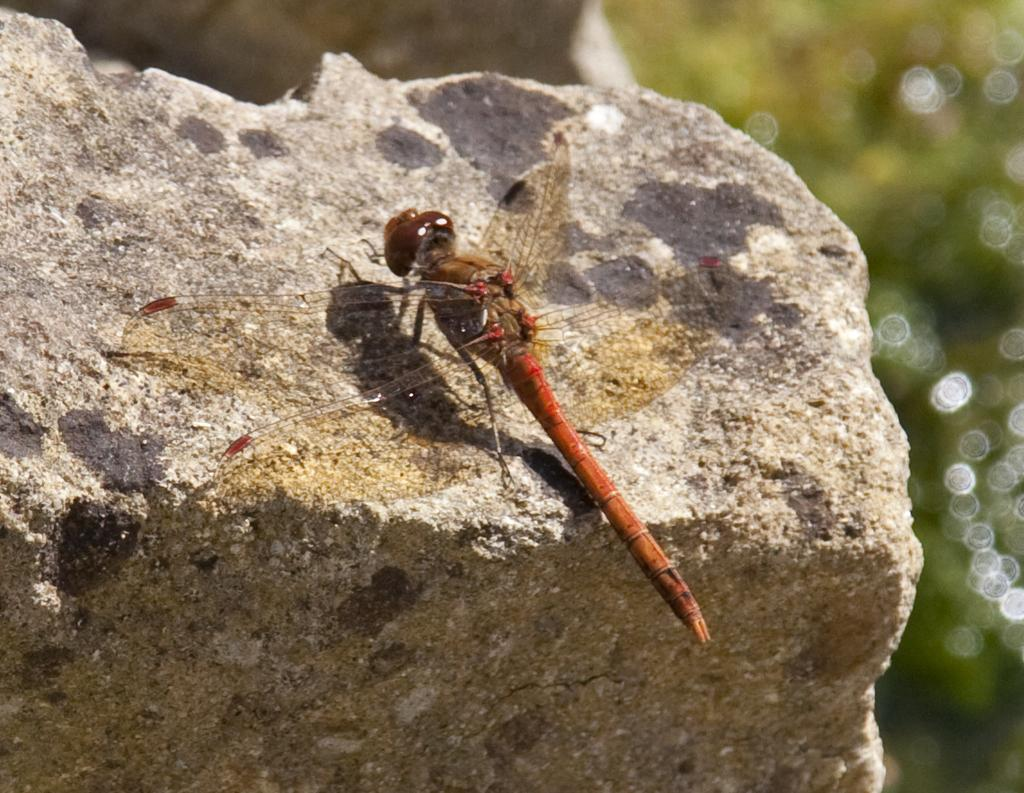What is the main subject of the image? There is an insect in the image. Where is the insect located? The insect is on a rock. Can you describe the background of the image? The background of the image is blurred. What type of haircut does the zebra have in the image? There is no zebra present in the image, so it is not possible to determine the type of haircut it might have. 